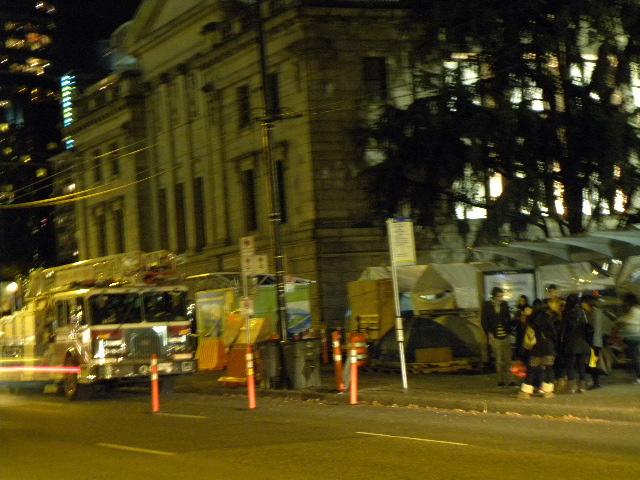Are there any people on the street?
Keep it brief. Yes. Is it nighttime?
Give a very brief answer. Yes. Are these people here for a drowning?
Give a very brief answer. No. What type of vehicle is on the left?
Keep it brief. Fire truck. 